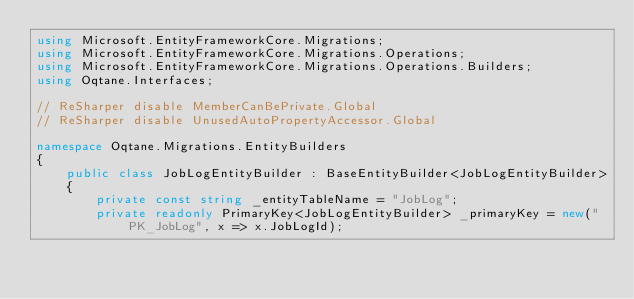Convert code to text. <code><loc_0><loc_0><loc_500><loc_500><_C#_>using Microsoft.EntityFrameworkCore.Migrations;
using Microsoft.EntityFrameworkCore.Migrations.Operations;
using Microsoft.EntityFrameworkCore.Migrations.Operations.Builders;
using Oqtane.Interfaces;

// ReSharper disable MemberCanBePrivate.Global
// ReSharper disable UnusedAutoPropertyAccessor.Global

namespace Oqtane.Migrations.EntityBuilders
{
    public class JobLogEntityBuilder : BaseEntityBuilder<JobLogEntityBuilder>
    {
        private const string _entityTableName = "JobLog";
        private readonly PrimaryKey<JobLogEntityBuilder> _primaryKey = new("PK_JobLog", x => x.JobLogId);</code> 